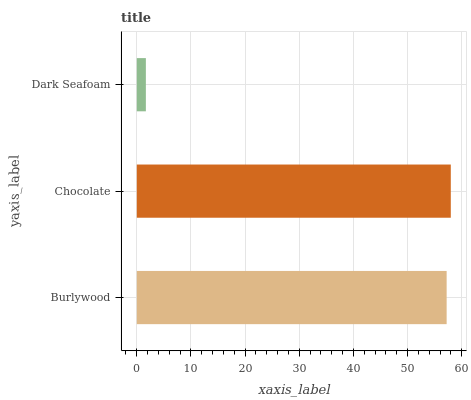Is Dark Seafoam the minimum?
Answer yes or no. Yes. Is Chocolate the maximum?
Answer yes or no. Yes. Is Chocolate the minimum?
Answer yes or no. No. Is Dark Seafoam the maximum?
Answer yes or no. No. Is Chocolate greater than Dark Seafoam?
Answer yes or no. Yes. Is Dark Seafoam less than Chocolate?
Answer yes or no. Yes. Is Dark Seafoam greater than Chocolate?
Answer yes or no. No. Is Chocolate less than Dark Seafoam?
Answer yes or no. No. Is Burlywood the high median?
Answer yes or no. Yes. Is Burlywood the low median?
Answer yes or no. Yes. Is Chocolate the high median?
Answer yes or no. No. Is Dark Seafoam the low median?
Answer yes or no. No. 